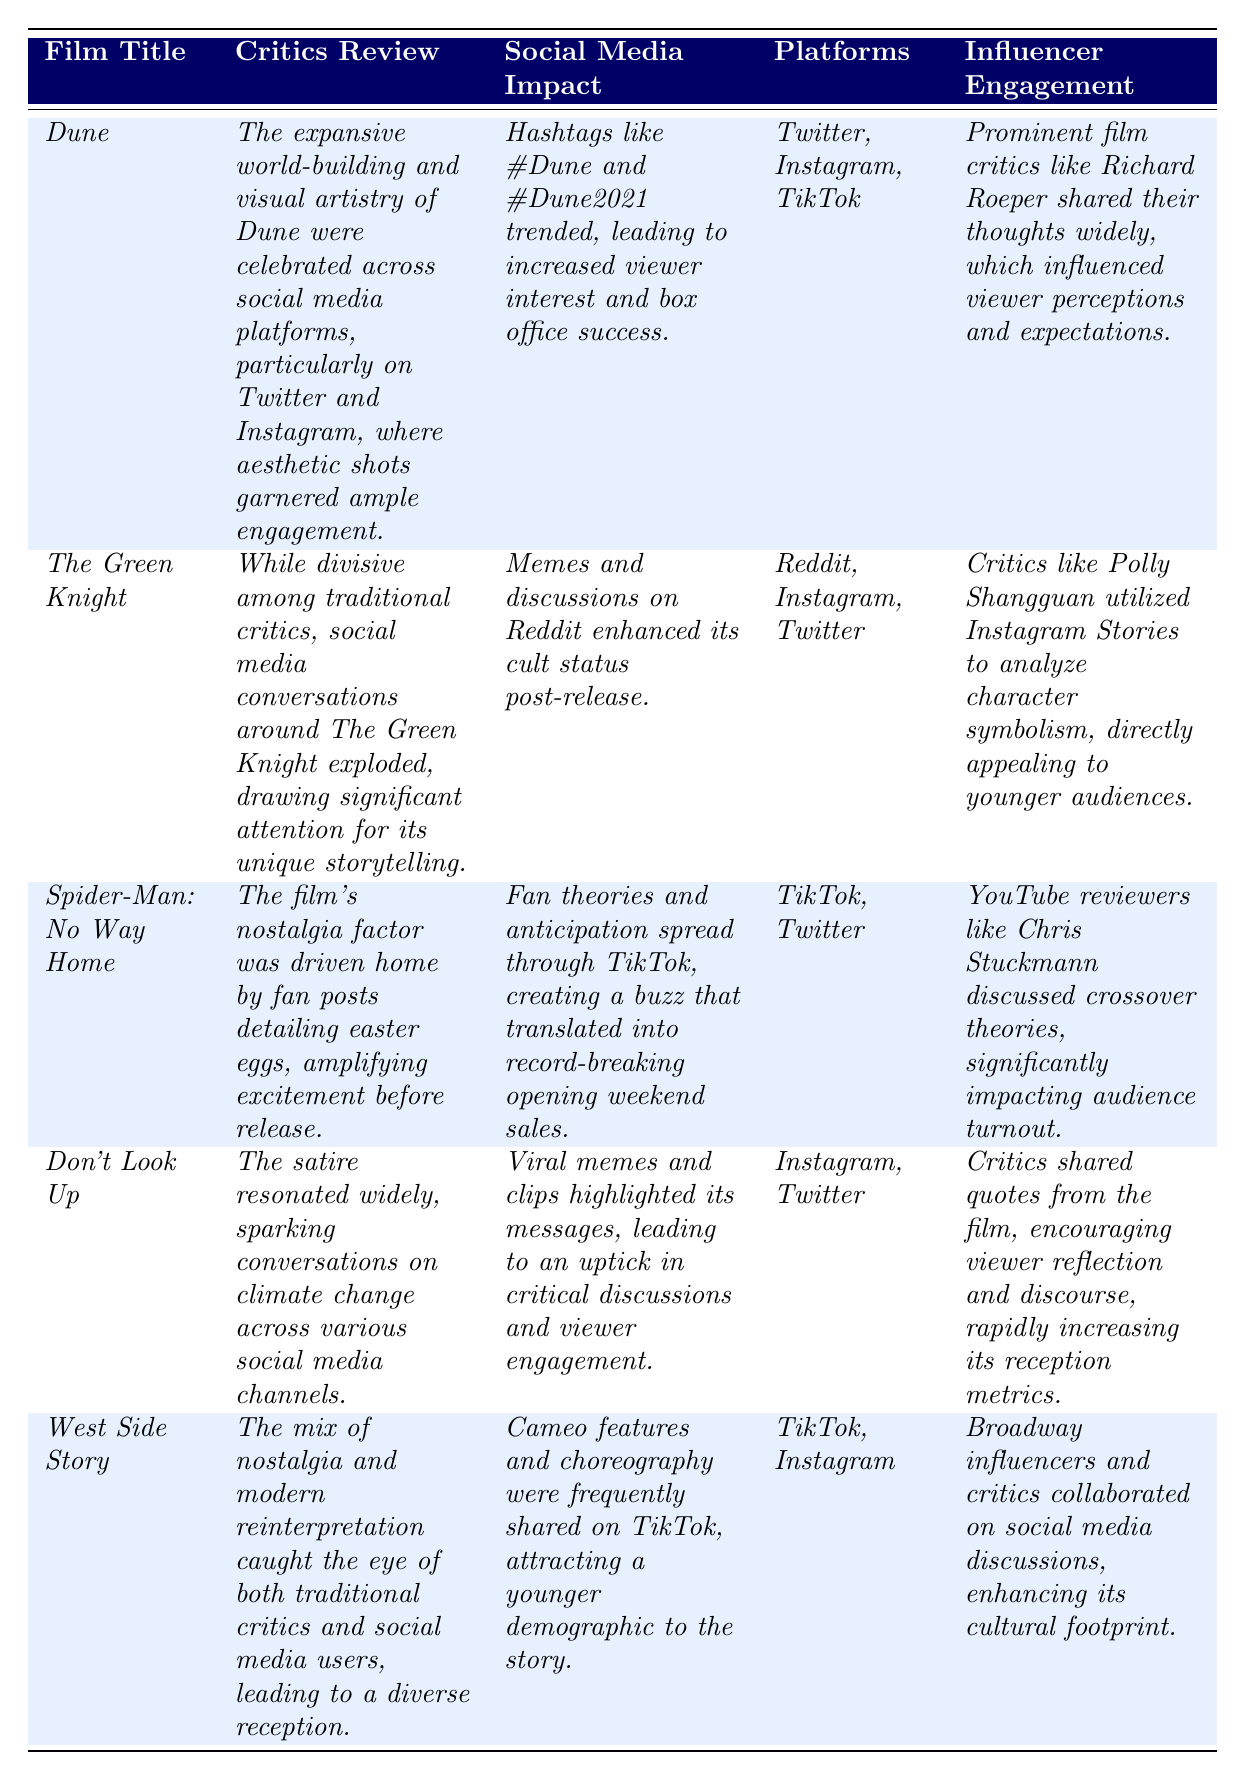What film had the most social media platforms mentioned? The films mentioned in the table are *Dune* (Twitter, Instagram, TikTok), *The Green Knight* (Reddit, Instagram, Twitter), *Spider-Man: No Way Home* (TikTok, Twitter), *Don't Look Up* (Instagram, Twitter), and *West Side Story* (TikTok, Instagram). Comparing them, *The Green Knight* mentions three: Reddit, Instagram, and Twitter.
Answer: The Green Knight Which film had its main discussion on TikTok? *Spider-Man: No Way Home* and *West Side Story* both had TikTok mentioned as a platform. However, *Spider-Man: No Way Home* emphasized TikTok as a key platform for fan theories and anticipation.
Answer: Spider-Man: No Way Home Did *Don't Look Up* receive impactful social media engagement? Yes, it did. The table states that viral memes and clips highlighted its messages and led to viewer engagement.
Answer: Yes Which film's critical reception was significantly influenced by memes on social media? *The Green Knight*'s critical reception was influenced significantly by memes, as the table highlights that memes and discussions on Reddit enhanced its cult status.
Answer: The Green Knight What is the common social media platform shared by *Dune* and *Don't Look Up*? Both films mention Instagram as a social media platform influencing their reception.
Answer: Instagram Which film had critics discussing character symbolism on social media? The table indicates that *The Green Knight* had critics discussing character symbolism, particularly through Instagram Stories.
Answer: The Green Knight How many films had their reception influenced by Twitter? Looking at the table, *Dune, The Green Knight, Spider-Man: No Way Home,* and *Don't Look Up* all mentioned Twitter as a platform, making it a total of four films.
Answer: Four What was the main factor in *Spider-Man: No Way Home*'s pre-release hype? The hype was primarily driven by fan posts detailing easter eggs, as stated in the critics' review.
Answer: Fan posts detailing easter eggs Which film had a diverse reception due to a mix of nostalgia and modern reinterpretation? *West Side Story* received a diverse reception because of its blend of nostalgia and a modern take on the classic story.
Answer: West Side Story Did influencer engagement have an impact on audience turnout for *Spider-Man: No Way Home*? Yes, the table notes that YouTube reviewers, such as Chris Stuckmann, significantly impacted audience turnout by discussing crossover theories.
Answer: Yes 